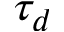<formula> <loc_0><loc_0><loc_500><loc_500>\tau _ { d }</formula> 